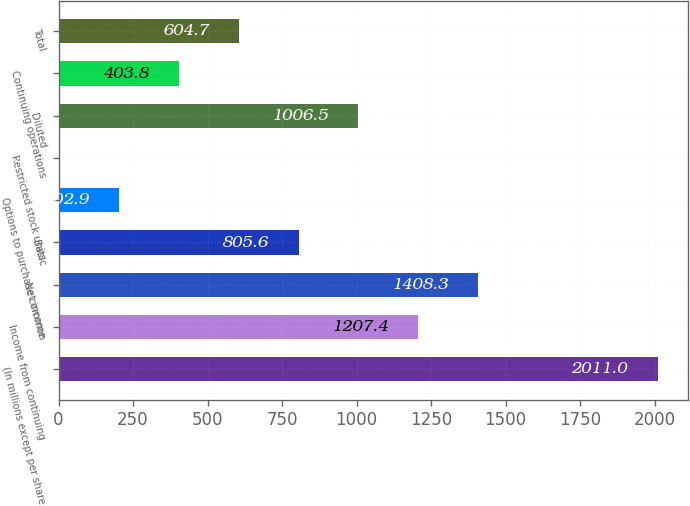Convert chart. <chart><loc_0><loc_0><loc_500><loc_500><bar_chart><fcel>(In millions except per share<fcel>Income from continuing<fcel>Net income<fcel>Basic<fcel>Options to purchase common<fcel>Restricted stock units<fcel>Diluted<fcel>Continuing operations<fcel>Total<nl><fcel>2011<fcel>1207.4<fcel>1408.3<fcel>805.6<fcel>202.9<fcel>2<fcel>1006.5<fcel>403.8<fcel>604.7<nl></chart> 